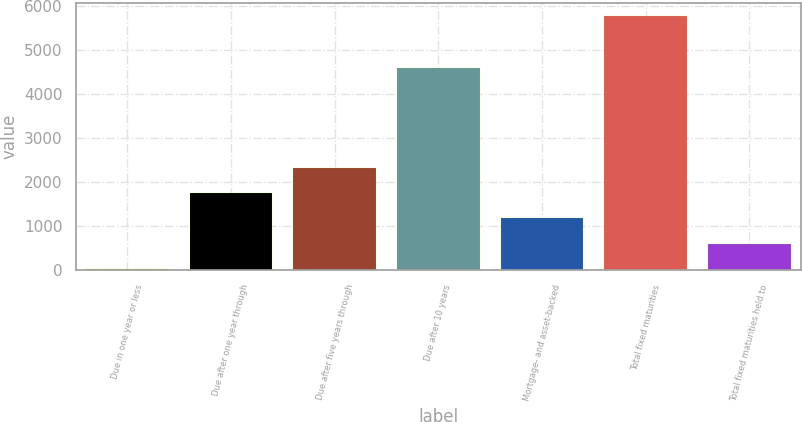Convert chart. <chart><loc_0><loc_0><loc_500><loc_500><bar_chart><fcel>Due in one year or less<fcel>Due after one year through<fcel>Due after five years through<fcel>Due after 10 years<fcel>Mortgage- and asset-backed<fcel>Total fixed maturities<fcel>Total fixed maturities held to<nl><fcel>27<fcel>1750.5<fcel>2325<fcel>4585<fcel>1176<fcel>5772<fcel>601.5<nl></chart> 